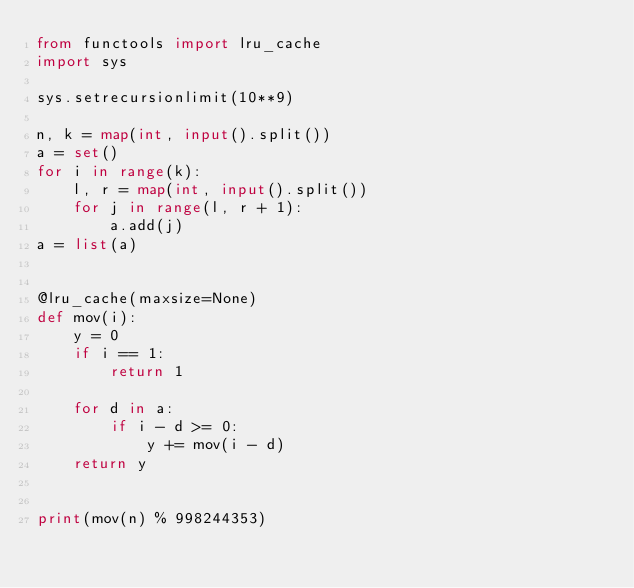Convert code to text. <code><loc_0><loc_0><loc_500><loc_500><_Python_>from functools import lru_cache
import sys

sys.setrecursionlimit(10**9)

n, k = map(int, input().split())
a = set()
for i in range(k):
    l, r = map(int, input().split())
    for j in range(l, r + 1):
        a.add(j)
a = list(a)


@lru_cache(maxsize=None)
def mov(i):
    y = 0
    if i == 1:
        return 1

    for d in a:
        if i - d >= 0:
            y += mov(i - d)
    return y


print(mov(n) % 998244353)</code> 